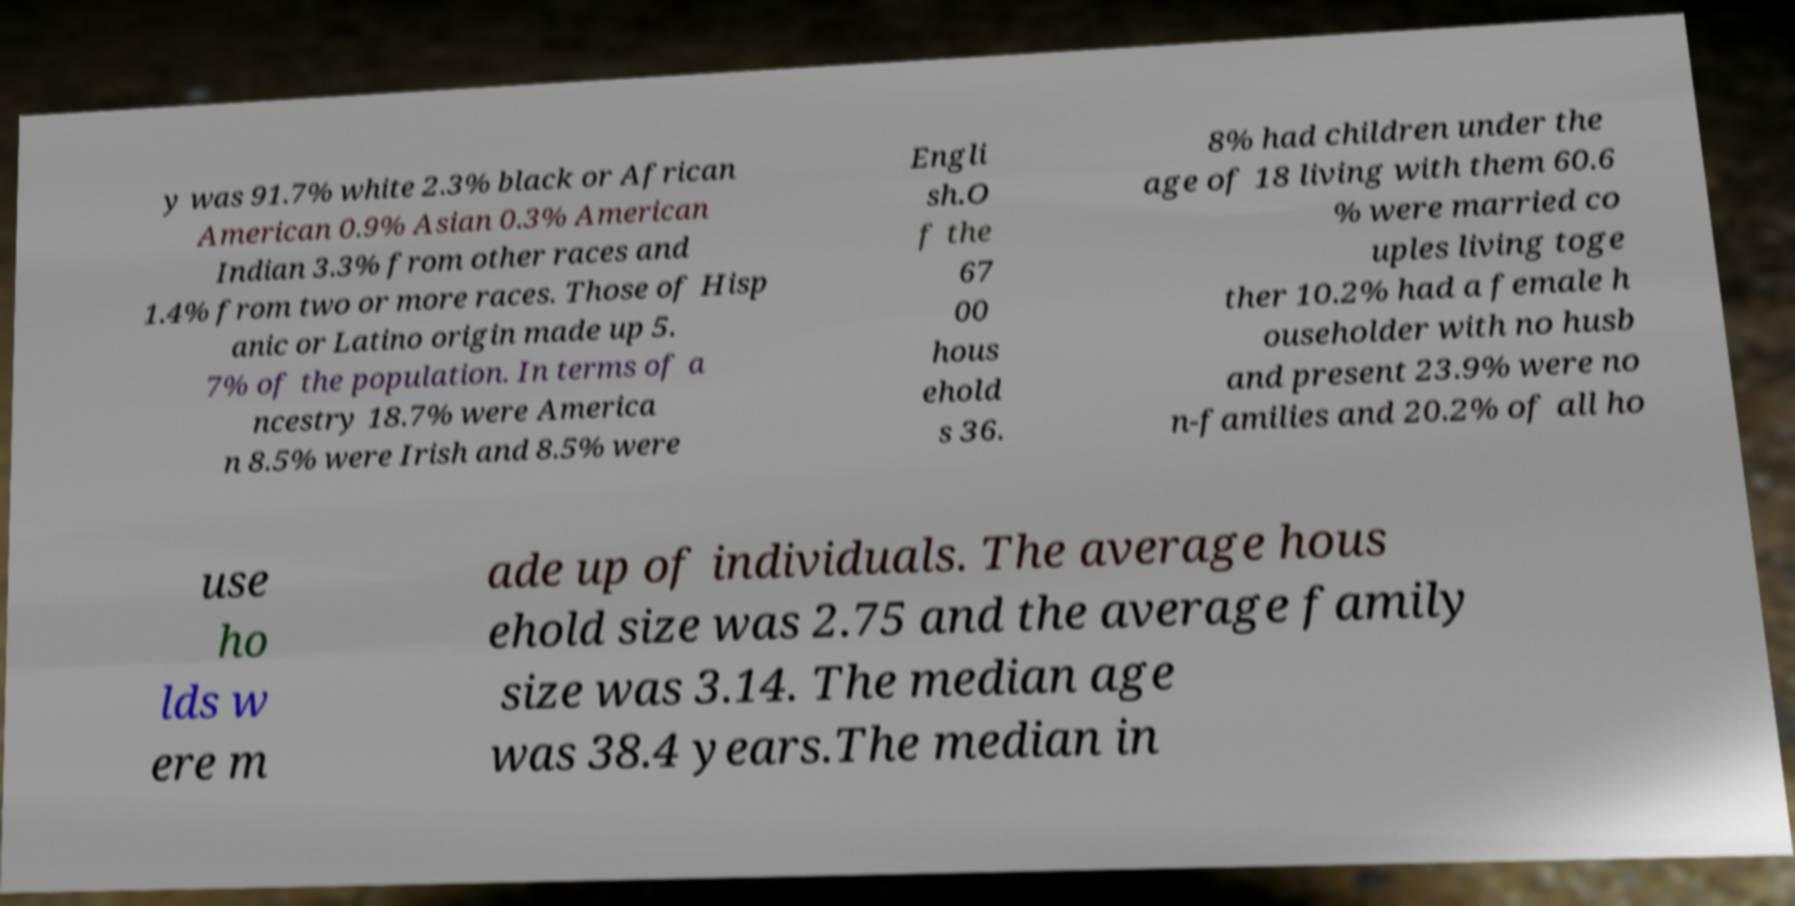Can you read and provide the text displayed in the image?This photo seems to have some interesting text. Can you extract and type it out for me? y was 91.7% white 2.3% black or African American 0.9% Asian 0.3% American Indian 3.3% from other races and 1.4% from two or more races. Those of Hisp anic or Latino origin made up 5. 7% of the population. In terms of a ncestry 18.7% were America n 8.5% were Irish and 8.5% were Engli sh.O f the 67 00 hous ehold s 36. 8% had children under the age of 18 living with them 60.6 % were married co uples living toge ther 10.2% had a female h ouseholder with no husb and present 23.9% were no n-families and 20.2% of all ho use ho lds w ere m ade up of individuals. The average hous ehold size was 2.75 and the average family size was 3.14. The median age was 38.4 years.The median in 